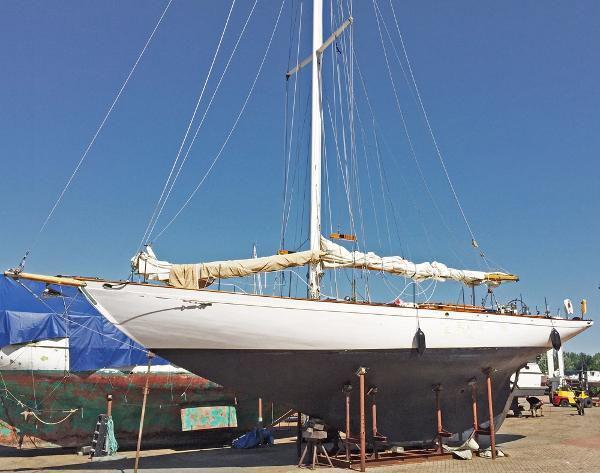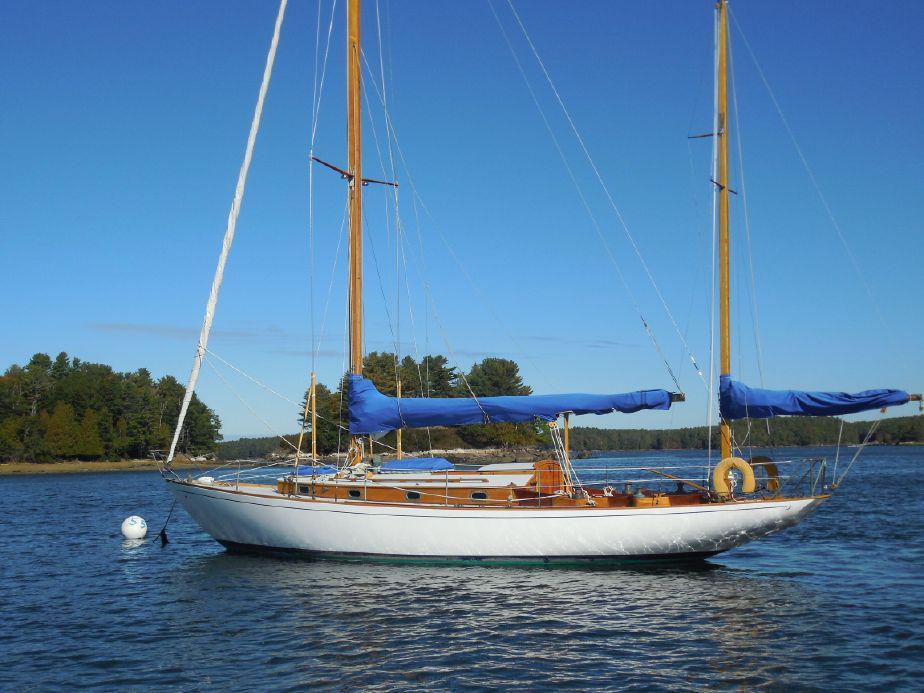The first image is the image on the left, the second image is the image on the right. Considering the images on both sides, is "One of the boats has three opened sails." valid? Answer yes or no. No. The first image is the image on the left, the second image is the image on the right. Evaluate the accuracy of this statement regarding the images: "The left and right image contains the same number of sailboat sailing on the water in opposite directions.". Is it true? Answer yes or no. No. 